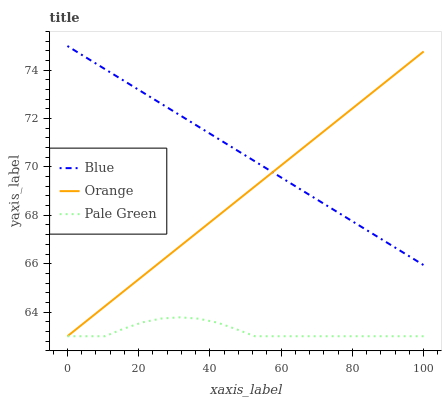Does Pale Green have the minimum area under the curve?
Answer yes or no. Yes. Does Blue have the maximum area under the curve?
Answer yes or no. Yes. Does Orange have the minimum area under the curve?
Answer yes or no. No. Does Orange have the maximum area under the curve?
Answer yes or no. No. Is Blue the smoothest?
Answer yes or no. Yes. Is Pale Green the roughest?
Answer yes or no. Yes. Is Orange the smoothest?
Answer yes or no. No. Is Orange the roughest?
Answer yes or no. No. Does Blue have the highest value?
Answer yes or no. Yes. Does Orange have the highest value?
Answer yes or no. No. Is Pale Green less than Blue?
Answer yes or no. Yes. Is Blue greater than Pale Green?
Answer yes or no. Yes. Does Blue intersect Orange?
Answer yes or no. Yes. Is Blue less than Orange?
Answer yes or no. No. Is Blue greater than Orange?
Answer yes or no. No. Does Pale Green intersect Blue?
Answer yes or no. No. 